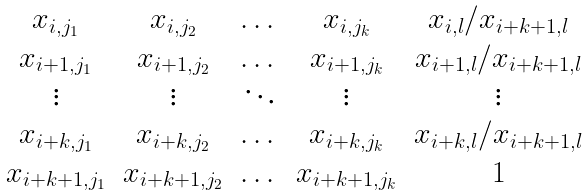Convert formula to latex. <formula><loc_0><loc_0><loc_500><loc_500>\begin{matrix} x _ { i , j _ { 1 } } & x _ { i , j _ { 2 } } & \dots & x _ { i , j _ { k } } & x _ { i , l } / x _ { i + k + 1 , l } \\ x _ { i + 1 , j _ { 1 } } & x _ { i + 1 , j _ { 2 } } & \dots & x _ { i + 1 , j _ { k } } & x _ { i + 1 , l } / x _ { i + k + 1 , l } \\ \vdots & \vdots & \ddots & \vdots & \vdots \\ x _ { i + k , j _ { 1 } } & x _ { i + k , j _ { 2 } } & \dots & x _ { i + k , j _ { k } } & x _ { i + k , l } / x _ { i + k + 1 , l } \\ x _ { i + k + 1 , j _ { 1 } } & x _ { i + k + 1 , j _ { 2 } } & \dots & x _ { i + k + 1 , j _ { k } } & 1 \end{matrix}</formula> 